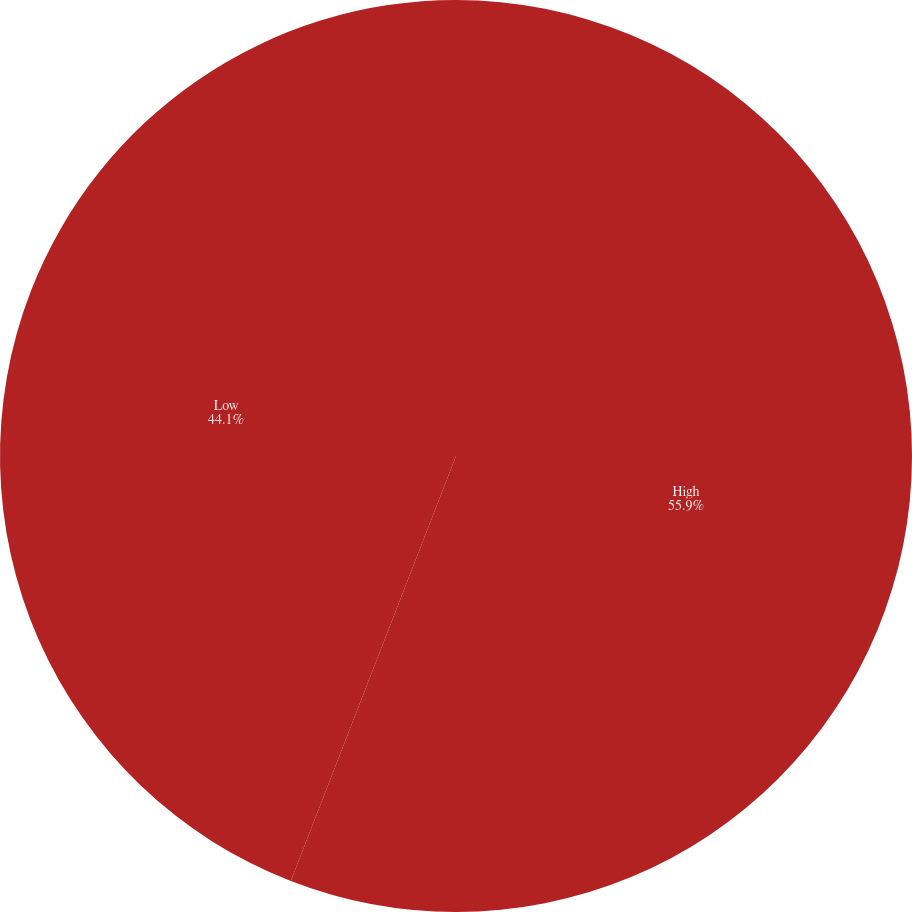<chart> <loc_0><loc_0><loc_500><loc_500><pie_chart><fcel>High<fcel>Low<nl><fcel>55.9%<fcel>44.1%<nl></chart> 